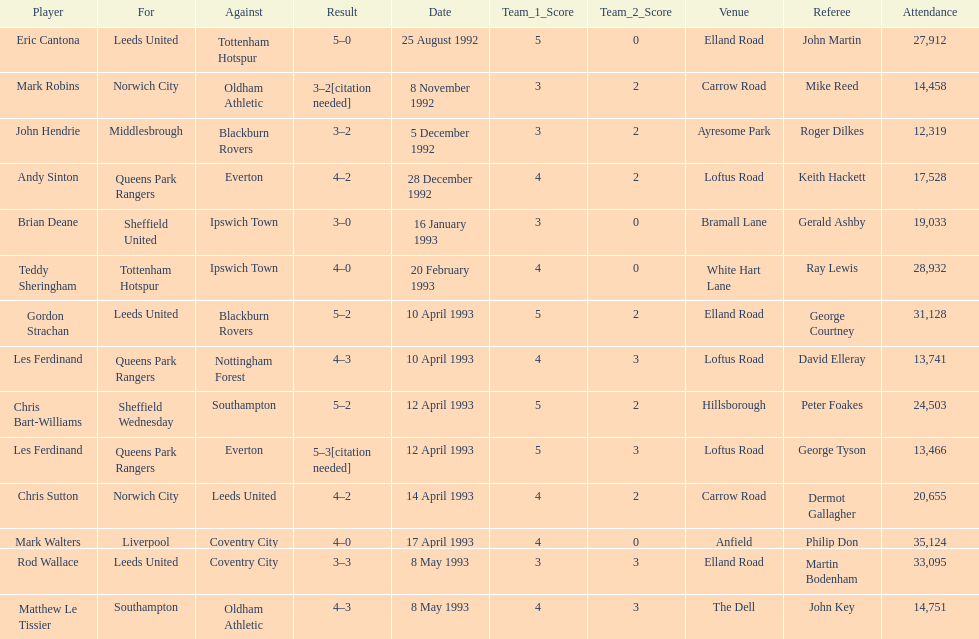Who is the single player hailing from france? Eric Cantona. 